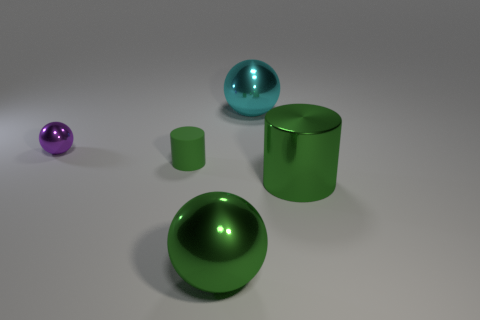What size is the metallic thing that is in front of the shiny thing to the right of the cyan sphere?
Keep it short and to the point. Large. Is the color of the metallic ball that is in front of the purple metallic object the same as the thing behind the tiny purple metallic thing?
Provide a succinct answer. No. There is a big green thing that is left of the big shiny ball that is behind the tiny cylinder; how many objects are on the left side of it?
Give a very brief answer. 2. What number of things are on the left side of the green metallic sphere and in front of the small shiny thing?
Make the answer very short. 1. Are there more small objects that are in front of the purple metallic sphere than large green metallic cylinders?
Provide a short and direct response. No. What number of other things are the same size as the cyan object?
Provide a short and direct response. 2. There is a metal ball that is the same color as the matte thing; what size is it?
Keep it short and to the point. Large. What number of tiny things are red metallic objects or shiny spheres?
Keep it short and to the point. 1. How many large cylinders are there?
Your answer should be compact. 1. Are there the same number of big green things behind the cyan metallic object and small green things that are on the left side of the purple thing?
Your answer should be compact. Yes. 